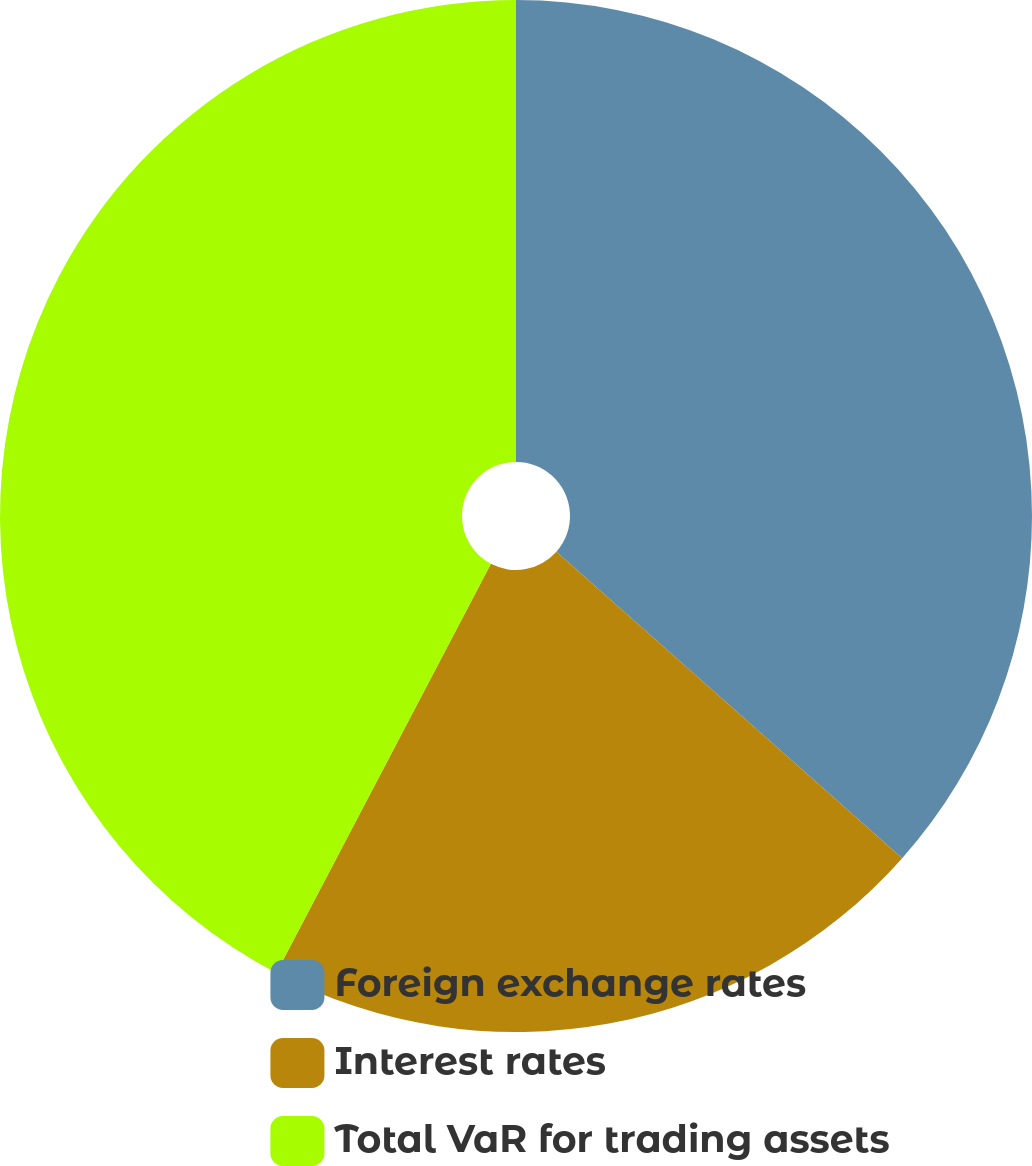Convert chart to OTSL. <chart><loc_0><loc_0><loc_500><loc_500><pie_chart><fcel>Foreign exchange rates<fcel>Interest rates<fcel>Total VaR for trading assets<nl><fcel>36.54%<fcel>21.15%<fcel>42.31%<nl></chart> 